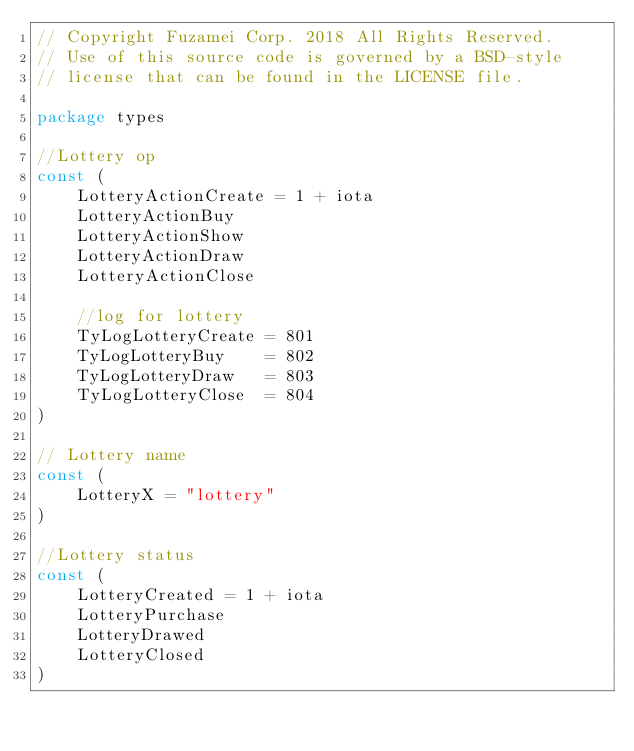<code> <loc_0><loc_0><loc_500><loc_500><_Go_>// Copyright Fuzamei Corp. 2018 All Rights Reserved.
// Use of this source code is governed by a BSD-style
// license that can be found in the LICENSE file.

package types

//Lottery op
const (
	LotteryActionCreate = 1 + iota
	LotteryActionBuy
	LotteryActionShow
	LotteryActionDraw
	LotteryActionClose

	//log for lottery
	TyLogLotteryCreate = 801
	TyLogLotteryBuy    = 802
	TyLogLotteryDraw   = 803
	TyLogLotteryClose  = 804
)

// Lottery name
const (
	LotteryX = "lottery"
)

//Lottery status
const (
	LotteryCreated = 1 + iota
	LotteryPurchase
	LotteryDrawed
	LotteryClosed
)
</code> 